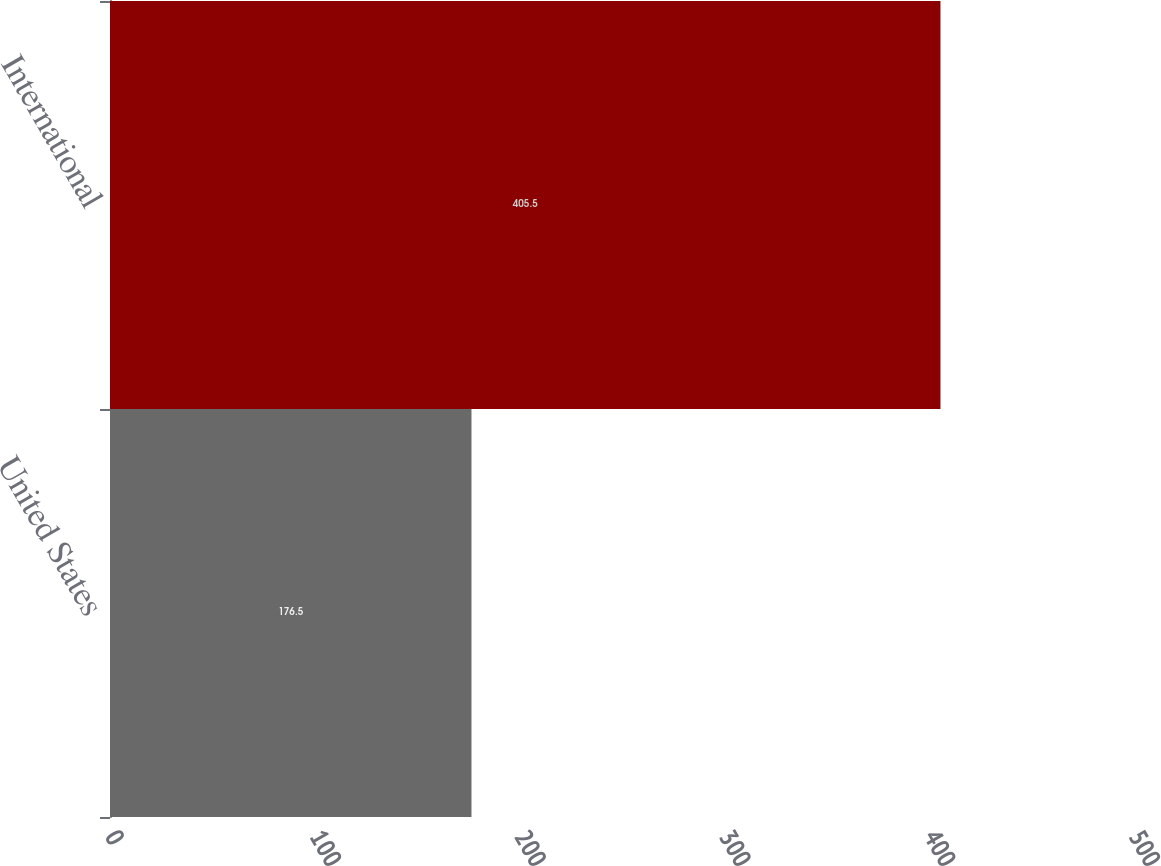<chart> <loc_0><loc_0><loc_500><loc_500><bar_chart><fcel>United States<fcel>International<nl><fcel>176.5<fcel>405.5<nl></chart> 